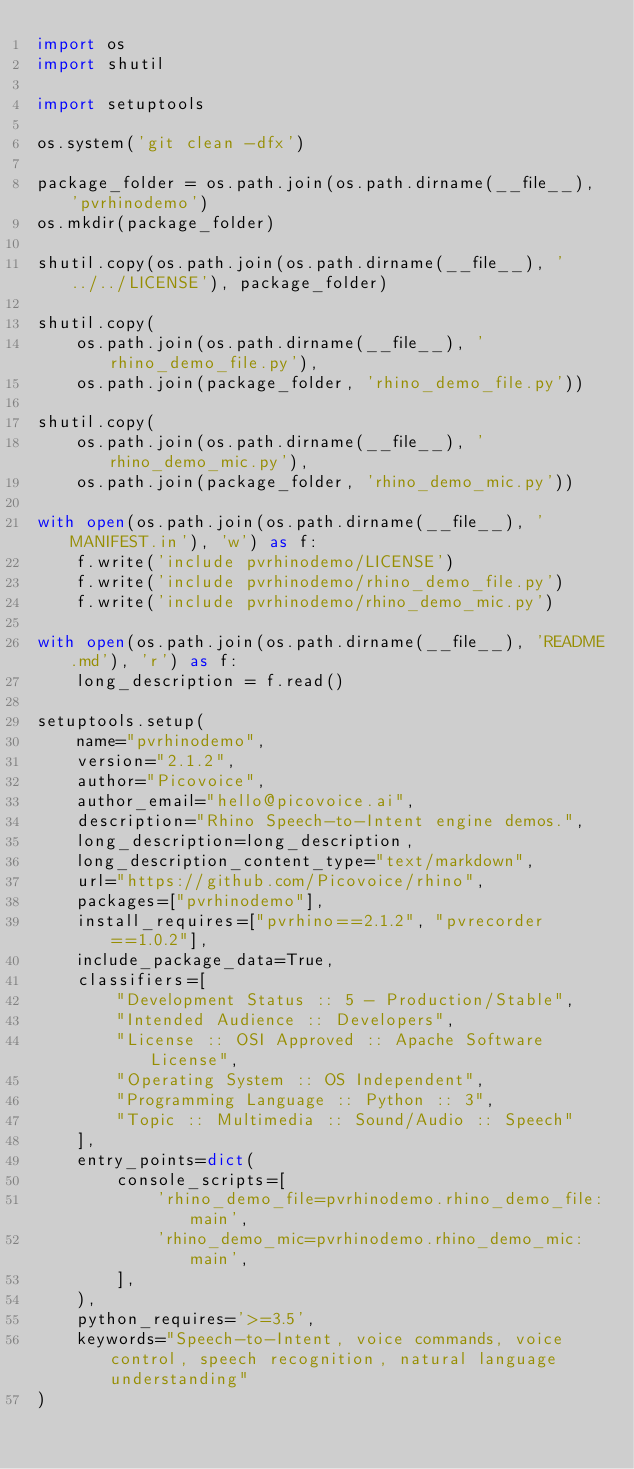Convert code to text. <code><loc_0><loc_0><loc_500><loc_500><_Python_>import os
import shutil

import setuptools

os.system('git clean -dfx')

package_folder = os.path.join(os.path.dirname(__file__), 'pvrhinodemo')
os.mkdir(package_folder)

shutil.copy(os.path.join(os.path.dirname(__file__), '../../LICENSE'), package_folder)

shutil.copy(
    os.path.join(os.path.dirname(__file__), 'rhino_demo_file.py'),
    os.path.join(package_folder, 'rhino_demo_file.py'))

shutil.copy(
    os.path.join(os.path.dirname(__file__), 'rhino_demo_mic.py'),
    os.path.join(package_folder, 'rhino_demo_mic.py'))

with open(os.path.join(os.path.dirname(__file__), 'MANIFEST.in'), 'w') as f:
    f.write('include pvrhinodemo/LICENSE')
    f.write('include pvrhinodemo/rhino_demo_file.py')
    f.write('include pvrhinodemo/rhino_demo_mic.py')

with open(os.path.join(os.path.dirname(__file__), 'README.md'), 'r') as f:
    long_description = f.read()

setuptools.setup(
    name="pvrhinodemo",
    version="2.1.2",
    author="Picovoice",
    author_email="hello@picovoice.ai",
    description="Rhino Speech-to-Intent engine demos.",
    long_description=long_description,
    long_description_content_type="text/markdown",
    url="https://github.com/Picovoice/rhino",
    packages=["pvrhinodemo"],
    install_requires=["pvrhino==2.1.2", "pvrecorder==1.0.2"],
    include_package_data=True,
    classifiers=[
        "Development Status :: 5 - Production/Stable",
        "Intended Audience :: Developers",
        "License :: OSI Approved :: Apache Software License",
        "Operating System :: OS Independent",
        "Programming Language :: Python :: 3",
        "Topic :: Multimedia :: Sound/Audio :: Speech"
    ],
    entry_points=dict(
        console_scripts=[
            'rhino_demo_file=pvrhinodemo.rhino_demo_file:main',
            'rhino_demo_mic=pvrhinodemo.rhino_demo_mic:main',
        ],
    ),
    python_requires='>=3.5',
    keywords="Speech-to-Intent, voice commands, voice control, speech recognition, natural language understanding"
)
</code> 